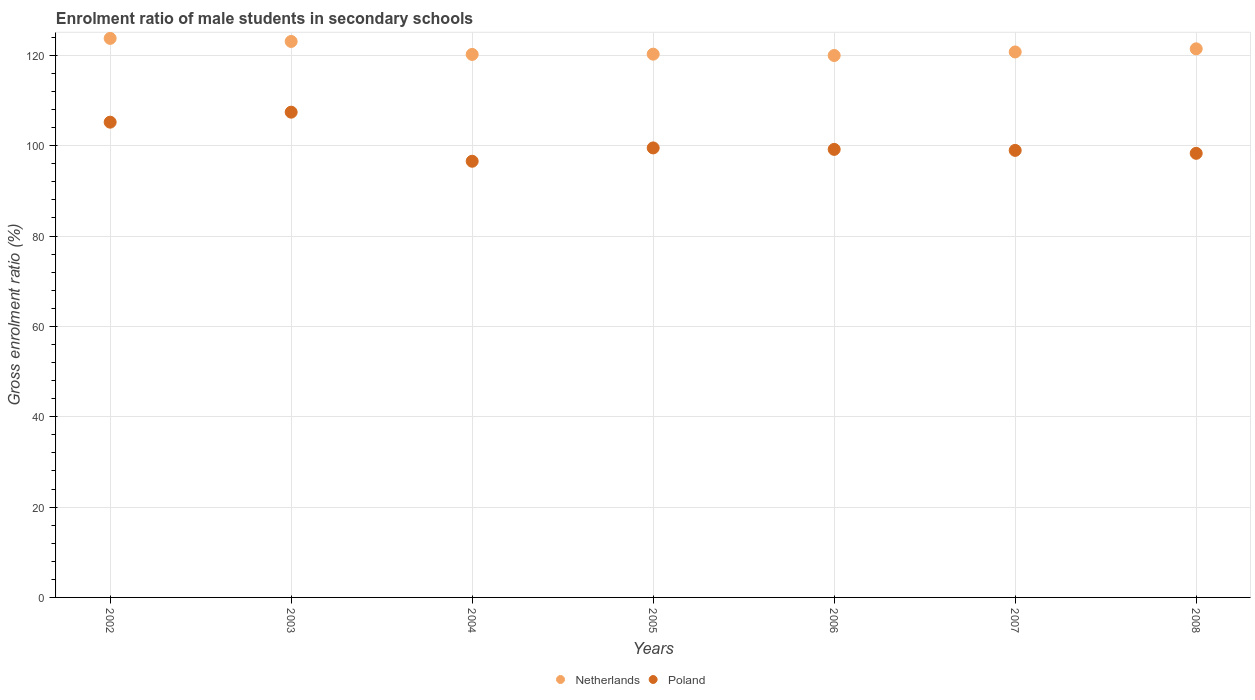Is the number of dotlines equal to the number of legend labels?
Offer a terse response. Yes. What is the enrolment ratio of male students in secondary schools in Netherlands in 2004?
Offer a very short reply. 120.21. Across all years, what is the maximum enrolment ratio of male students in secondary schools in Netherlands?
Provide a succinct answer. 123.76. Across all years, what is the minimum enrolment ratio of male students in secondary schools in Netherlands?
Provide a short and direct response. 119.97. What is the total enrolment ratio of male students in secondary schools in Netherlands in the graph?
Offer a very short reply. 849.5. What is the difference between the enrolment ratio of male students in secondary schools in Poland in 2005 and that in 2007?
Ensure brevity in your answer.  0.55. What is the difference between the enrolment ratio of male students in secondary schools in Poland in 2006 and the enrolment ratio of male students in secondary schools in Netherlands in 2002?
Your answer should be compact. -24.57. What is the average enrolment ratio of male students in secondary schools in Netherlands per year?
Keep it short and to the point. 121.36. In the year 2007, what is the difference between the enrolment ratio of male students in secondary schools in Netherlands and enrolment ratio of male students in secondary schools in Poland?
Your answer should be compact. 21.79. What is the ratio of the enrolment ratio of male students in secondary schools in Netherlands in 2005 to that in 2007?
Offer a terse response. 1. Is the difference between the enrolment ratio of male students in secondary schools in Netherlands in 2007 and 2008 greater than the difference between the enrolment ratio of male students in secondary schools in Poland in 2007 and 2008?
Provide a succinct answer. No. What is the difference between the highest and the second highest enrolment ratio of male students in secondary schools in Netherlands?
Ensure brevity in your answer.  0.68. What is the difference between the highest and the lowest enrolment ratio of male students in secondary schools in Netherlands?
Your answer should be very brief. 3.79. Is the enrolment ratio of male students in secondary schools in Poland strictly greater than the enrolment ratio of male students in secondary schools in Netherlands over the years?
Offer a terse response. No. How many dotlines are there?
Your response must be concise. 2. Are the values on the major ticks of Y-axis written in scientific E-notation?
Give a very brief answer. No. Does the graph contain any zero values?
Provide a succinct answer. No. Does the graph contain grids?
Provide a succinct answer. Yes. How many legend labels are there?
Provide a succinct answer. 2. What is the title of the graph?
Offer a terse response. Enrolment ratio of male students in secondary schools. What is the Gross enrolment ratio (%) of Netherlands in 2002?
Offer a very short reply. 123.76. What is the Gross enrolment ratio (%) in Poland in 2002?
Give a very brief answer. 105.21. What is the Gross enrolment ratio (%) in Netherlands in 2003?
Ensure brevity in your answer.  123.08. What is the Gross enrolment ratio (%) of Poland in 2003?
Provide a short and direct response. 107.43. What is the Gross enrolment ratio (%) in Netherlands in 2004?
Your answer should be very brief. 120.21. What is the Gross enrolment ratio (%) in Poland in 2004?
Your answer should be very brief. 96.56. What is the Gross enrolment ratio (%) in Netherlands in 2005?
Offer a terse response. 120.27. What is the Gross enrolment ratio (%) of Poland in 2005?
Your response must be concise. 99.51. What is the Gross enrolment ratio (%) of Netherlands in 2006?
Your answer should be very brief. 119.97. What is the Gross enrolment ratio (%) in Poland in 2006?
Your answer should be compact. 99.19. What is the Gross enrolment ratio (%) of Netherlands in 2007?
Offer a very short reply. 120.76. What is the Gross enrolment ratio (%) of Poland in 2007?
Your response must be concise. 98.96. What is the Gross enrolment ratio (%) in Netherlands in 2008?
Give a very brief answer. 121.45. What is the Gross enrolment ratio (%) of Poland in 2008?
Provide a succinct answer. 98.31. Across all years, what is the maximum Gross enrolment ratio (%) of Netherlands?
Offer a very short reply. 123.76. Across all years, what is the maximum Gross enrolment ratio (%) in Poland?
Your answer should be compact. 107.43. Across all years, what is the minimum Gross enrolment ratio (%) in Netherlands?
Offer a very short reply. 119.97. Across all years, what is the minimum Gross enrolment ratio (%) of Poland?
Your answer should be compact. 96.56. What is the total Gross enrolment ratio (%) of Netherlands in the graph?
Provide a succinct answer. 849.5. What is the total Gross enrolment ratio (%) in Poland in the graph?
Keep it short and to the point. 705.18. What is the difference between the Gross enrolment ratio (%) in Netherlands in 2002 and that in 2003?
Your answer should be very brief. 0.68. What is the difference between the Gross enrolment ratio (%) in Poland in 2002 and that in 2003?
Keep it short and to the point. -2.21. What is the difference between the Gross enrolment ratio (%) in Netherlands in 2002 and that in 2004?
Provide a short and direct response. 3.55. What is the difference between the Gross enrolment ratio (%) of Poland in 2002 and that in 2004?
Offer a very short reply. 8.65. What is the difference between the Gross enrolment ratio (%) of Netherlands in 2002 and that in 2005?
Ensure brevity in your answer.  3.49. What is the difference between the Gross enrolment ratio (%) in Poland in 2002 and that in 2005?
Provide a succinct answer. 5.7. What is the difference between the Gross enrolment ratio (%) of Netherlands in 2002 and that in 2006?
Keep it short and to the point. 3.79. What is the difference between the Gross enrolment ratio (%) of Poland in 2002 and that in 2006?
Your response must be concise. 6.02. What is the difference between the Gross enrolment ratio (%) of Netherlands in 2002 and that in 2007?
Make the answer very short. 3. What is the difference between the Gross enrolment ratio (%) of Poland in 2002 and that in 2007?
Your response must be concise. 6.25. What is the difference between the Gross enrolment ratio (%) of Netherlands in 2002 and that in 2008?
Provide a succinct answer. 2.31. What is the difference between the Gross enrolment ratio (%) of Poland in 2002 and that in 2008?
Give a very brief answer. 6.9. What is the difference between the Gross enrolment ratio (%) of Netherlands in 2003 and that in 2004?
Give a very brief answer. 2.87. What is the difference between the Gross enrolment ratio (%) in Poland in 2003 and that in 2004?
Offer a very short reply. 10.87. What is the difference between the Gross enrolment ratio (%) of Netherlands in 2003 and that in 2005?
Offer a terse response. 2.81. What is the difference between the Gross enrolment ratio (%) of Poland in 2003 and that in 2005?
Keep it short and to the point. 7.91. What is the difference between the Gross enrolment ratio (%) in Netherlands in 2003 and that in 2006?
Provide a short and direct response. 3.11. What is the difference between the Gross enrolment ratio (%) in Poland in 2003 and that in 2006?
Make the answer very short. 8.24. What is the difference between the Gross enrolment ratio (%) in Netherlands in 2003 and that in 2007?
Give a very brief answer. 2.32. What is the difference between the Gross enrolment ratio (%) of Poland in 2003 and that in 2007?
Your answer should be compact. 8.46. What is the difference between the Gross enrolment ratio (%) in Netherlands in 2003 and that in 2008?
Keep it short and to the point. 1.63. What is the difference between the Gross enrolment ratio (%) of Poland in 2003 and that in 2008?
Provide a succinct answer. 9.11. What is the difference between the Gross enrolment ratio (%) in Netherlands in 2004 and that in 2005?
Make the answer very short. -0.06. What is the difference between the Gross enrolment ratio (%) of Poland in 2004 and that in 2005?
Provide a succinct answer. -2.95. What is the difference between the Gross enrolment ratio (%) in Netherlands in 2004 and that in 2006?
Your answer should be compact. 0.24. What is the difference between the Gross enrolment ratio (%) of Poland in 2004 and that in 2006?
Keep it short and to the point. -2.63. What is the difference between the Gross enrolment ratio (%) in Netherlands in 2004 and that in 2007?
Make the answer very short. -0.55. What is the difference between the Gross enrolment ratio (%) in Poland in 2004 and that in 2007?
Your response must be concise. -2.4. What is the difference between the Gross enrolment ratio (%) of Netherlands in 2004 and that in 2008?
Provide a succinct answer. -1.24. What is the difference between the Gross enrolment ratio (%) in Poland in 2004 and that in 2008?
Provide a short and direct response. -1.75. What is the difference between the Gross enrolment ratio (%) in Netherlands in 2005 and that in 2006?
Your answer should be compact. 0.3. What is the difference between the Gross enrolment ratio (%) in Poland in 2005 and that in 2006?
Your answer should be very brief. 0.32. What is the difference between the Gross enrolment ratio (%) of Netherlands in 2005 and that in 2007?
Keep it short and to the point. -0.49. What is the difference between the Gross enrolment ratio (%) in Poland in 2005 and that in 2007?
Offer a terse response. 0.55. What is the difference between the Gross enrolment ratio (%) in Netherlands in 2005 and that in 2008?
Keep it short and to the point. -1.18. What is the difference between the Gross enrolment ratio (%) of Poland in 2005 and that in 2008?
Your response must be concise. 1.2. What is the difference between the Gross enrolment ratio (%) in Netherlands in 2006 and that in 2007?
Offer a terse response. -0.78. What is the difference between the Gross enrolment ratio (%) of Poland in 2006 and that in 2007?
Make the answer very short. 0.22. What is the difference between the Gross enrolment ratio (%) of Netherlands in 2006 and that in 2008?
Offer a terse response. -1.48. What is the difference between the Gross enrolment ratio (%) of Poland in 2006 and that in 2008?
Your response must be concise. 0.87. What is the difference between the Gross enrolment ratio (%) of Netherlands in 2007 and that in 2008?
Provide a short and direct response. -0.69. What is the difference between the Gross enrolment ratio (%) in Poland in 2007 and that in 2008?
Give a very brief answer. 0.65. What is the difference between the Gross enrolment ratio (%) of Netherlands in 2002 and the Gross enrolment ratio (%) of Poland in 2003?
Your answer should be compact. 16.33. What is the difference between the Gross enrolment ratio (%) in Netherlands in 2002 and the Gross enrolment ratio (%) in Poland in 2004?
Offer a terse response. 27.2. What is the difference between the Gross enrolment ratio (%) in Netherlands in 2002 and the Gross enrolment ratio (%) in Poland in 2005?
Give a very brief answer. 24.25. What is the difference between the Gross enrolment ratio (%) of Netherlands in 2002 and the Gross enrolment ratio (%) of Poland in 2006?
Give a very brief answer. 24.57. What is the difference between the Gross enrolment ratio (%) of Netherlands in 2002 and the Gross enrolment ratio (%) of Poland in 2007?
Ensure brevity in your answer.  24.79. What is the difference between the Gross enrolment ratio (%) of Netherlands in 2002 and the Gross enrolment ratio (%) of Poland in 2008?
Your answer should be compact. 25.45. What is the difference between the Gross enrolment ratio (%) of Netherlands in 2003 and the Gross enrolment ratio (%) of Poland in 2004?
Provide a succinct answer. 26.52. What is the difference between the Gross enrolment ratio (%) of Netherlands in 2003 and the Gross enrolment ratio (%) of Poland in 2005?
Offer a very short reply. 23.57. What is the difference between the Gross enrolment ratio (%) of Netherlands in 2003 and the Gross enrolment ratio (%) of Poland in 2006?
Your response must be concise. 23.89. What is the difference between the Gross enrolment ratio (%) in Netherlands in 2003 and the Gross enrolment ratio (%) in Poland in 2007?
Your answer should be compact. 24.12. What is the difference between the Gross enrolment ratio (%) of Netherlands in 2003 and the Gross enrolment ratio (%) of Poland in 2008?
Your answer should be compact. 24.77. What is the difference between the Gross enrolment ratio (%) in Netherlands in 2004 and the Gross enrolment ratio (%) in Poland in 2005?
Keep it short and to the point. 20.7. What is the difference between the Gross enrolment ratio (%) in Netherlands in 2004 and the Gross enrolment ratio (%) in Poland in 2006?
Ensure brevity in your answer.  21.02. What is the difference between the Gross enrolment ratio (%) in Netherlands in 2004 and the Gross enrolment ratio (%) in Poland in 2007?
Ensure brevity in your answer.  21.24. What is the difference between the Gross enrolment ratio (%) of Netherlands in 2004 and the Gross enrolment ratio (%) of Poland in 2008?
Give a very brief answer. 21.9. What is the difference between the Gross enrolment ratio (%) of Netherlands in 2005 and the Gross enrolment ratio (%) of Poland in 2006?
Ensure brevity in your answer.  21.08. What is the difference between the Gross enrolment ratio (%) in Netherlands in 2005 and the Gross enrolment ratio (%) in Poland in 2007?
Offer a terse response. 21.3. What is the difference between the Gross enrolment ratio (%) in Netherlands in 2005 and the Gross enrolment ratio (%) in Poland in 2008?
Your answer should be very brief. 21.95. What is the difference between the Gross enrolment ratio (%) of Netherlands in 2006 and the Gross enrolment ratio (%) of Poland in 2007?
Make the answer very short. 21.01. What is the difference between the Gross enrolment ratio (%) of Netherlands in 2006 and the Gross enrolment ratio (%) of Poland in 2008?
Keep it short and to the point. 21.66. What is the difference between the Gross enrolment ratio (%) in Netherlands in 2007 and the Gross enrolment ratio (%) in Poland in 2008?
Make the answer very short. 22.44. What is the average Gross enrolment ratio (%) in Netherlands per year?
Offer a very short reply. 121.36. What is the average Gross enrolment ratio (%) in Poland per year?
Make the answer very short. 100.74. In the year 2002, what is the difference between the Gross enrolment ratio (%) in Netherlands and Gross enrolment ratio (%) in Poland?
Your response must be concise. 18.55. In the year 2003, what is the difference between the Gross enrolment ratio (%) of Netherlands and Gross enrolment ratio (%) of Poland?
Provide a short and direct response. 15.66. In the year 2004, what is the difference between the Gross enrolment ratio (%) of Netherlands and Gross enrolment ratio (%) of Poland?
Give a very brief answer. 23.65. In the year 2005, what is the difference between the Gross enrolment ratio (%) in Netherlands and Gross enrolment ratio (%) in Poland?
Offer a terse response. 20.76. In the year 2006, what is the difference between the Gross enrolment ratio (%) in Netherlands and Gross enrolment ratio (%) in Poland?
Make the answer very short. 20.78. In the year 2007, what is the difference between the Gross enrolment ratio (%) in Netherlands and Gross enrolment ratio (%) in Poland?
Provide a short and direct response. 21.79. In the year 2008, what is the difference between the Gross enrolment ratio (%) of Netherlands and Gross enrolment ratio (%) of Poland?
Make the answer very short. 23.14. What is the ratio of the Gross enrolment ratio (%) of Poland in 2002 to that in 2003?
Keep it short and to the point. 0.98. What is the ratio of the Gross enrolment ratio (%) of Netherlands in 2002 to that in 2004?
Give a very brief answer. 1.03. What is the ratio of the Gross enrolment ratio (%) in Poland in 2002 to that in 2004?
Your response must be concise. 1.09. What is the ratio of the Gross enrolment ratio (%) of Poland in 2002 to that in 2005?
Ensure brevity in your answer.  1.06. What is the ratio of the Gross enrolment ratio (%) of Netherlands in 2002 to that in 2006?
Ensure brevity in your answer.  1.03. What is the ratio of the Gross enrolment ratio (%) in Poland in 2002 to that in 2006?
Ensure brevity in your answer.  1.06. What is the ratio of the Gross enrolment ratio (%) in Netherlands in 2002 to that in 2007?
Your response must be concise. 1.02. What is the ratio of the Gross enrolment ratio (%) of Poland in 2002 to that in 2007?
Keep it short and to the point. 1.06. What is the ratio of the Gross enrolment ratio (%) in Poland in 2002 to that in 2008?
Make the answer very short. 1.07. What is the ratio of the Gross enrolment ratio (%) in Netherlands in 2003 to that in 2004?
Provide a short and direct response. 1.02. What is the ratio of the Gross enrolment ratio (%) in Poland in 2003 to that in 2004?
Keep it short and to the point. 1.11. What is the ratio of the Gross enrolment ratio (%) of Netherlands in 2003 to that in 2005?
Offer a very short reply. 1.02. What is the ratio of the Gross enrolment ratio (%) of Poland in 2003 to that in 2005?
Ensure brevity in your answer.  1.08. What is the ratio of the Gross enrolment ratio (%) of Netherlands in 2003 to that in 2006?
Offer a very short reply. 1.03. What is the ratio of the Gross enrolment ratio (%) in Poland in 2003 to that in 2006?
Ensure brevity in your answer.  1.08. What is the ratio of the Gross enrolment ratio (%) of Netherlands in 2003 to that in 2007?
Offer a very short reply. 1.02. What is the ratio of the Gross enrolment ratio (%) in Poland in 2003 to that in 2007?
Provide a succinct answer. 1.09. What is the ratio of the Gross enrolment ratio (%) in Netherlands in 2003 to that in 2008?
Offer a very short reply. 1.01. What is the ratio of the Gross enrolment ratio (%) in Poland in 2003 to that in 2008?
Ensure brevity in your answer.  1.09. What is the ratio of the Gross enrolment ratio (%) in Poland in 2004 to that in 2005?
Offer a very short reply. 0.97. What is the ratio of the Gross enrolment ratio (%) of Poland in 2004 to that in 2006?
Provide a short and direct response. 0.97. What is the ratio of the Gross enrolment ratio (%) in Netherlands in 2004 to that in 2007?
Keep it short and to the point. 1. What is the ratio of the Gross enrolment ratio (%) of Poland in 2004 to that in 2007?
Provide a succinct answer. 0.98. What is the ratio of the Gross enrolment ratio (%) in Poland in 2004 to that in 2008?
Your answer should be very brief. 0.98. What is the ratio of the Gross enrolment ratio (%) in Netherlands in 2005 to that in 2006?
Offer a terse response. 1. What is the ratio of the Gross enrolment ratio (%) of Poland in 2005 to that in 2006?
Your answer should be compact. 1. What is the ratio of the Gross enrolment ratio (%) of Netherlands in 2005 to that in 2007?
Make the answer very short. 1. What is the ratio of the Gross enrolment ratio (%) of Poland in 2005 to that in 2007?
Give a very brief answer. 1.01. What is the ratio of the Gross enrolment ratio (%) of Netherlands in 2005 to that in 2008?
Your answer should be very brief. 0.99. What is the ratio of the Gross enrolment ratio (%) of Poland in 2005 to that in 2008?
Your response must be concise. 1.01. What is the ratio of the Gross enrolment ratio (%) in Netherlands in 2006 to that in 2007?
Your answer should be very brief. 0.99. What is the ratio of the Gross enrolment ratio (%) in Netherlands in 2006 to that in 2008?
Make the answer very short. 0.99. What is the ratio of the Gross enrolment ratio (%) of Poland in 2006 to that in 2008?
Your answer should be compact. 1.01. What is the ratio of the Gross enrolment ratio (%) in Poland in 2007 to that in 2008?
Provide a succinct answer. 1.01. What is the difference between the highest and the second highest Gross enrolment ratio (%) of Netherlands?
Keep it short and to the point. 0.68. What is the difference between the highest and the second highest Gross enrolment ratio (%) in Poland?
Make the answer very short. 2.21. What is the difference between the highest and the lowest Gross enrolment ratio (%) in Netherlands?
Your answer should be compact. 3.79. What is the difference between the highest and the lowest Gross enrolment ratio (%) of Poland?
Make the answer very short. 10.87. 